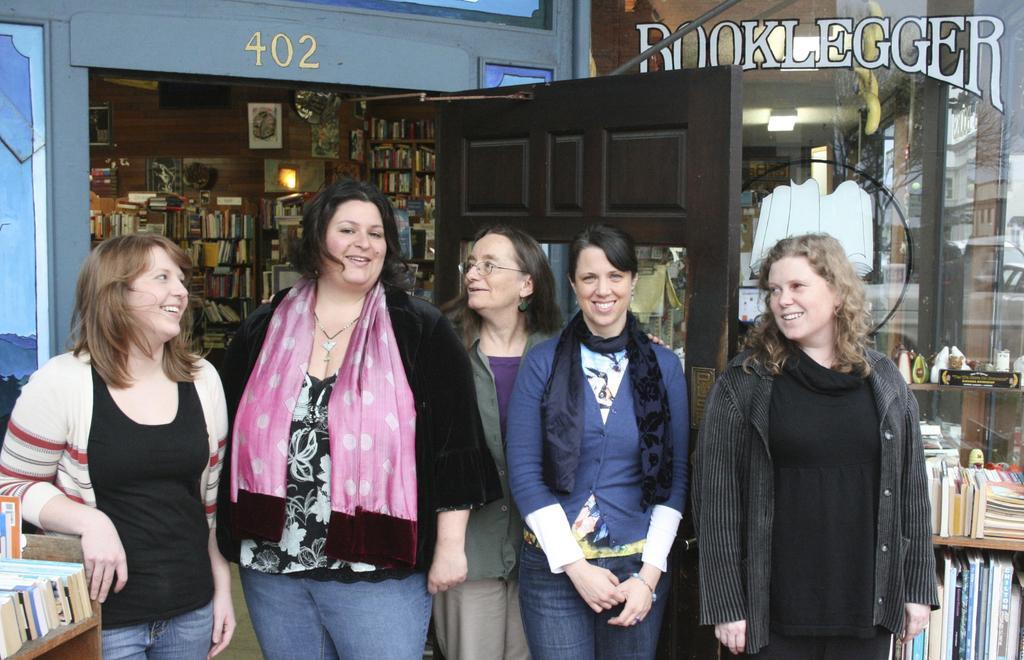How would you summarize this image in a sentence or two? In this image we can see few people, there are few books, photo frames to the wall and a light in the room, there is a door behind the people, there are books on the racks beside the people and a glass with text and image. 